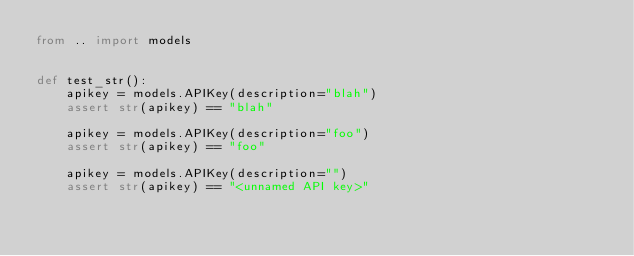<code> <loc_0><loc_0><loc_500><loc_500><_Python_>from .. import models


def test_str():
    apikey = models.APIKey(description="blah")
    assert str(apikey) == "blah"

    apikey = models.APIKey(description="foo")
    assert str(apikey) == "foo"

    apikey = models.APIKey(description="")
    assert str(apikey) == "<unnamed API key>"
</code> 